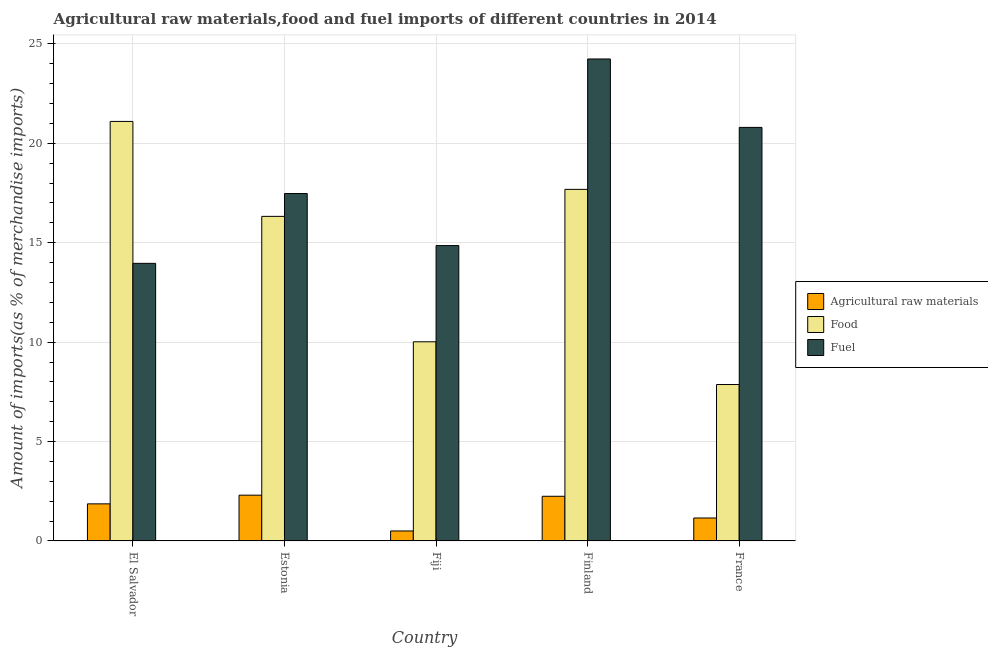How many different coloured bars are there?
Give a very brief answer. 3. Are the number of bars per tick equal to the number of legend labels?
Ensure brevity in your answer.  Yes. Are the number of bars on each tick of the X-axis equal?
Your response must be concise. Yes. What is the label of the 3rd group of bars from the left?
Your answer should be very brief. Fiji. In how many cases, is the number of bars for a given country not equal to the number of legend labels?
Your answer should be compact. 0. What is the percentage of raw materials imports in Finland?
Your answer should be very brief. 2.25. Across all countries, what is the maximum percentage of food imports?
Keep it short and to the point. 21.1. Across all countries, what is the minimum percentage of raw materials imports?
Offer a terse response. 0.5. In which country was the percentage of food imports maximum?
Make the answer very short. El Salvador. In which country was the percentage of fuel imports minimum?
Provide a short and direct response. El Salvador. What is the total percentage of raw materials imports in the graph?
Your response must be concise. 8.08. What is the difference between the percentage of raw materials imports in Finland and that in France?
Offer a terse response. 1.09. What is the difference between the percentage of raw materials imports in Estonia and the percentage of food imports in France?
Your answer should be compact. -5.56. What is the average percentage of fuel imports per country?
Offer a very short reply. 18.27. What is the difference between the percentage of fuel imports and percentage of food imports in El Salvador?
Provide a succinct answer. -7.14. What is the ratio of the percentage of food imports in Estonia to that in Finland?
Ensure brevity in your answer.  0.92. Is the difference between the percentage of fuel imports in Fiji and France greater than the difference between the percentage of raw materials imports in Fiji and France?
Provide a succinct answer. No. What is the difference between the highest and the second highest percentage of food imports?
Provide a short and direct response. 3.42. What is the difference between the highest and the lowest percentage of raw materials imports?
Your answer should be very brief. 1.8. What does the 2nd bar from the left in El Salvador represents?
Your answer should be very brief. Food. What does the 1st bar from the right in El Salvador represents?
Provide a succinct answer. Fuel. Is it the case that in every country, the sum of the percentage of raw materials imports and percentage of food imports is greater than the percentage of fuel imports?
Make the answer very short. No. Are all the bars in the graph horizontal?
Offer a terse response. No. Does the graph contain any zero values?
Your response must be concise. No. Where does the legend appear in the graph?
Keep it short and to the point. Center right. How many legend labels are there?
Offer a terse response. 3. What is the title of the graph?
Provide a succinct answer. Agricultural raw materials,food and fuel imports of different countries in 2014. Does "Ages 20-60" appear as one of the legend labels in the graph?
Make the answer very short. No. What is the label or title of the X-axis?
Your response must be concise. Country. What is the label or title of the Y-axis?
Offer a very short reply. Amount of imports(as % of merchandise imports). What is the Amount of imports(as % of merchandise imports) of Agricultural raw materials in El Salvador?
Your response must be concise. 1.87. What is the Amount of imports(as % of merchandise imports) of Food in El Salvador?
Offer a very short reply. 21.1. What is the Amount of imports(as % of merchandise imports) of Fuel in El Salvador?
Provide a short and direct response. 13.96. What is the Amount of imports(as % of merchandise imports) in Agricultural raw materials in Estonia?
Provide a short and direct response. 2.3. What is the Amount of imports(as % of merchandise imports) of Food in Estonia?
Ensure brevity in your answer.  16.32. What is the Amount of imports(as % of merchandise imports) of Fuel in Estonia?
Provide a succinct answer. 17.47. What is the Amount of imports(as % of merchandise imports) of Agricultural raw materials in Fiji?
Provide a short and direct response. 0.5. What is the Amount of imports(as % of merchandise imports) of Food in Fiji?
Your answer should be compact. 10.02. What is the Amount of imports(as % of merchandise imports) in Fuel in Fiji?
Keep it short and to the point. 14.86. What is the Amount of imports(as % of merchandise imports) in Agricultural raw materials in Finland?
Offer a very short reply. 2.25. What is the Amount of imports(as % of merchandise imports) in Food in Finland?
Provide a short and direct response. 17.68. What is the Amount of imports(as % of merchandise imports) in Fuel in Finland?
Provide a short and direct response. 24.24. What is the Amount of imports(as % of merchandise imports) of Agricultural raw materials in France?
Offer a terse response. 1.16. What is the Amount of imports(as % of merchandise imports) in Food in France?
Make the answer very short. 7.87. What is the Amount of imports(as % of merchandise imports) in Fuel in France?
Give a very brief answer. 20.8. Across all countries, what is the maximum Amount of imports(as % of merchandise imports) of Agricultural raw materials?
Offer a terse response. 2.3. Across all countries, what is the maximum Amount of imports(as % of merchandise imports) in Food?
Your answer should be compact. 21.1. Across all countries, what is the maximum Amount of imports(as % of merchandise imports) of Fuel?
Ensure brevity in your answer.  24.24. Across all countries, what is the minimum Amount of imports(as % of merchandise imports) of Agricultural raw materials?
Ensure brevity in your answer.  0.5. Across all countries, what is the minimum Amount of imports(as % of merchandise imports) of Food?
Ensure brevity in your answer.  7.87. Across all countries, what is the minimum Amount of imports(as % of merchandise imports) in Fuel?
Your answer should be compact. 13.96. What is the total Amount of imports(as % of merchandise imports) of Agricultural raw materials in the graph?
Provide a succinct answer. 8.08. What is the total Amount of imports(as % of merchandise imports) in Food in the graph?
Offer a very short reply. 72.99. What is the total Amount of imports(as % of merchandise imports) in Fuel in the graph?
Give a very brief answer. 91.33. What is the difference between the Amount of imports(as % of merchandise imports) in Agricultural raw materials in El Salvador and that in Estonia?
Your answer should be compact. -0.44. What is the difference between the Amount of imports(as % of merchandise imports) of Food in El Salvador and that in Estonia?
Your answer should be compact. 4.77. What is the difference between the Amount of imports(as % of merchandise imports) in Fuel in El Salvador and that in Estonia?
Your response must be concise. -3.51. What is the difference between the Amount of imports(as % of merchandise imports) of Agricultural raw materials in El Salvador and that in Fiji?
Offer a terse response. 1.36. What is the difference between the Amount of imports(as % of merchandise imports) of Food in El Salvador and that in Fiji?
Offer a terse response. 11.08. What is the difference between the Amount of imports(as % of merchandise imports) in Fuel in El Salvador and that in Fiji?
Your response must be concise. -0.89. What is the difference between the Amount of imports(as % of merchandise imports) in Agricultural raw materials in El Salvador and that in Finland?
Provide a succinct answer. -0.38. What is the difference between the Amount of imports(as % of merchandise imports) of Food in El Salvador and that in Finland?
Keep it short and to the point. 3.42. What is the difference between the Amount of imports(as % of merchandise imports) in Fuel in El Salvador and that in Finland?
Your answer should be compact. -10.28. What is the difference between the Amount of imports(as % of merchandise imports) of Agricultural raw materials in El Salvador and that in France?
Your response must be concise. 0.71. What is the difference between the Amount of imports(as % of merchandise imports) of Food in El Salvador and that in France?
Give a very brief answer. 13.23. What is the difference between the Amount of imports(as % of merchandise imports) of Fuel in El Salvador and that in France?
Give a very brief answer. -6.84. What is the difference between the Amount of imports(as % of merchandise imports) of Agricultural raw materials in Estonia and that in Fiji?
Offer a terse response. 1.8. What is the difference between the Amount of imports(as % of merchandise imports) of Food in Estonia and that in Fiji?
Your answer should be compact. 6.31. What is the difference between the Amount of imports(as % of merchandise imports) in Fuel in Estonia and that in Fiji?
Offer a terse response. 2.62. What is the difference between the Amount of imports(as % of merchandise imports) of Agricultural raw materials in Estonia and that in Finland?
Your response must be concise. 0.06. What is the difference between the Amount of imports(as % of merchandise imports) of Food in Estonia and that in Finland?
Offer a very short reply. -1.36. What is the difference between the Amount of imports(as % of merchandise imports) in Fuel in Estonia and that in Finland?
Provide a short and direct response. -6.77. What is the difference between the Amount of imports(as % of merchandise imports) of Agricultural raw materials in Estonia and that in France?
Offer a very short reply. 1.15. What is the difference between the Amount of imports(as % of merchandise imports) in Food in Estonia and that in France?
Keep it short and to the point. 8.46. What is the difference between the Amount of imports(as % of merchandise imports) in Fuel in Estonia and that in France?
Your response must be concise. -3.33. What is the difference between the Amount of imports(as % of merchandise imports) of Agricultural raw materials in Fiji and that in Finland?
Provide a succinct answer. -1.74. What is the difference between the Amount of imports(as % of merchandise imports) of Food in Fiji and that in Finland?
Your answer should be very brief. -7.67. What is the difference between the Amount of imports(as % of merchandise imports) of Fuel in Fiji and that in Finland?
Ensure brevity in your answer.  -9.38. What is the difference between the Amount of imports(as % of merchandise imports) of Agricultural raw materials in Fiji and that in France?
Offer a very short reply. -0.65. What is the difference between the Amount of imports(as % of merchandise imports) of Food in Fiji and that in France?
Your response must be concise. 2.15. What is the difference between the Amount of imports(as % of merchandise imports) in Fuel in Fiji and that in France?
Your answer should be very brief. -5.94. What is the difference between the Amount of imports(as % of merchandise imports) of Agricultural raw materials in Finland and that in France?
Provide a succinct answer. 1.09. What is the difference between the Amount of imports(as % of merchandise imports) of Food in Finland and that in France?
Provide a succinct answer. 9.81. What is the difference between the Amount of imports(as % of merchandise imports) in Fuel in Finland and that in France?
Ensure brevity in your answer.  3.44. What is the difference between the Amount of imports(as % of merchandise imports) in Agricultural raw materials in El Salvador and the Amount of imports(as % of merchandise imports) in Food in Estonia?
Keep it short and to the point. -14.46. What is the difference between the Amount of imports(as % of merchandise imports) of Agricultural raw materials in El Salvador and the Amount of imports(as % of merchandise imports) of Fuel in Estonia?
Your response must be concise. -15.61. What is the difference between the Amount of imports(as % of merchandise imports) in Food in El Salvador and the Amount of imports(as % of merchandise imports) in Fuel in Estonia?
Provide a short and direct response. 3.63. What is the difference between the Amount of imports(as % of merchandise imports) of Agricultural raw materials in El Salvador and the Amount of imports(as % of merchandise imports) of Food in Fiji?
Keep it short and to the point. -8.15. What is the difference between the Amount of imports(as % of merchandise imports) in Agricultural raw materials in El Salvador and the Amount of imports(as % of merchandise imports) in Fuel in Fiji?
Provide a short and direct response. -12.99. What is the difference between the Amount of imports(as % of merchandise imports) of Food in El Salvador and the Amount of imports(as % of merchandise imports) of Fuel in Fiji?
Keep it short and to the point. 6.24. What is the difference between the Amount of imports(as % of merchandise imports) in Agricultural raw materials in El Salvador and the Amount of imports(as % of merchandise imports) in Food in Finland?
Ensure brevity in your answer.  -15.82. What is the difference between the Amount of imports(as % of merchandise imports) of Agricultural raw materials in El Salvador and the Amount of imports(as % of merchandise imports) of Fuel in Finland?
Provide a short and direct response. -22.37. What is the difference between the Amount of imports(as % of merchandise imports) of Food in El Salvador and the Amount of imports(as % of merchandise imports) of Fuel in Finland?
Your response must be concise. -3.14. What is the difference between the Amount of imports(as % of merchandise imports) in Agricultural raw materials in El Salvador and the Amount of imports(as % of merchandise imports) in Food in France?
Your answer should be very brief. -6. What is the difference between the Amount of imports(as % of merchandise imports) of Agricultural raw materials in El Salvador and the Amount of imports(as % of merchandise imports) of Fuel in France?
Ensure brevity in your answer.  -18.93. What is the difference between the Amount of imports(as % of merchandise imports) of Food in El Salvador and the Amount of imports(as % of merchandise imports) of Fuel in France?
Your answer should be very brief. 0.3. What is the difference between the Amount of imports(as % of merchandise imports) in Agricultural raw materials in Estonia and the Amount of imports(as % of merchandise imports) in Food in Fiji?
Give a very brief answer. -7.71. What is the difference between the Amount of imports(as % of merchandise imports) in Agricultural raw materials in Estonia and the Amount of imports(as % of merchandise imports) in Fuel in Fiji?
Make the answer very short. -12.55. What is the difference between the Amount of imports(as % of merchandise imports) of Food in Estonia and the Amount of imports(as % of merchandise imports) of Fuel in Fiji?
Keep it short and to the point. 1.47. What is the difference between the Amount of imports(as % of merchandise imports) in Agricultural raw materials in Estonia and the Amount of imports(as % of merchandise imports) in Food in Finland?
Offer a very short reply. -15.38. What is the difference between the Amount of imports(as % of merchandise imports) in Agricultural raw materials in Estonia and the Amount of imports(as % of merchandise imports) in Fuel in Finland?
Provide a succinct answer. -21.94. What is the difference between the Amount of imports(as % of merchandise imports) of Food in Estonia and the Amount of imports(as % of merchandise imports) of Fuel in Finland?
Make the answer very short. -7.92. What is the difference between the Amount of imports(as % of merchandise imports) of Agricultural raw materials in Estonia and the Amount of imports(as % of merchandise imports) of Food in France?
Provide a short and direct response. -5.56. What is the difference between the Amount of imports(as % of merchandise imports) of Agricultural raw materials in Estonia and the Amount of imports(as % of merchandise imports) of Fuel in France?
Your answer should be very brief. -18.5. What is the difference between the Amount of imports(as % of merchandise imports) in Food in Estonia and the Amount of imports(as % of merchandise imports) in Fuel in France?
Your response must be concise. -4.47. What is the difference between the Amount of imports(as % of merchandise imports) of Agricultural raw materials in Fiji and the Amount of imports(as % of merchandise imports) of Food in Finland?
Your answer should be very brief. -17.18. What is the difference between the Amount of imports(as % of merchandise imports) of Agricultural raw materials in Fiji and the Amount of imports(as % of merchandise imports) of Fuel in Finland?
Give a very brief answer. -23.74. What is the difference between the Amount of imports(as % of merchandise imports) in Food in Fiji and the Amount of imports(as % of merchandise imports) in Fuel in Finland?
Your response must be concise. -14.22. What is the difference between the Amount of imports(as % of merchandise imports) of Agricultural raw materials in Fiji and the Amount of imports(as % of merchandise imports) of Food in France?
Provide a succinct answer. -7.36. What is the difference between the Amount of imports(as % of merchandise imports) of Agricultural raw materials in Fiji and the Amount of imports(as % of merchandise imports) of Fuel in France?
Offer a very short reply. -20.3. What is the difference between the Amount of imports(as % of merchandise imports) in Food in Fiji and the Amount of imports(as % of merchandise imports) in Fuel in France?
Provide a succinct answer. -10.78. What is the difference between the Amount of imports(as % of merchandise imports) of Agricultural raw materials in Finland and the Amount of imports(as % of merchandise imports) of Food in France?
Provide a succinct answer. -5.62. What is the difference between the Amount of imports(as % of merchandise imports) in Agricultural raw materials in Finland and the Amount of imports(as % of merchandise imports) in Fuel in France?
Your answer should be very brief. -18.55. What is the difference between the Amount of imports(as % of merchandise imports) in Food in Finland and the Amount of imports(as % of merchandise imports) in Fuel in France?
Keep it short and to the point. -3.12. What is the average Amount of imports(as % of merchandise imports) in Agricultural raw materials per country?
Provide a short and direct response. 1.62. What is the average Amount of imports(as % of merchandise imports) in Food per country?
Your response must be concise. 14.6. What is the average Amount of imports(as % of merchandise imports) of Fuel per country?
Keep it short and to the point. 18.27. What is the difference between the Amount of imports(as % of merchandise imports) in Agricultural raw materials and Amount of imports(as % of merchandise imports) in Food in El Salvador?
Your response must be concise. -19.23. What is the difference between the Amount of imports(as % of merchandise imports) in Agricultural raw materials and Amount of imports(as % of merchandise imports) in Fuel in El Salvador?
Your answer should be compact. -12.1. What is the difference between the Amount of imports(as % of merchandise imports) in Food and Amount of imports(as % of merchandise imports) in Fuel in El Salvador?
Offer a very short reply. 7.14. What is the difference between the Amount of imports(as % of merchandise imports) of Agricultural raw materials and Amount of imports(as % of merchandise imports) of Food in Estonia?
Make the answer very short. -14.02. What is the difference between the Amount of imports(as % of merchandise imports) in Agricultural raw materials and Amount of imports(as % of merchandise imports) in Fuel in Estonia?
Ensure brevity in your answer.  -15.17. What is the difference between the Amount of imports(as % of merchandise imports) in Food and Amount of imports(as % of merchandise imports) in Fuel in Estonia?
Your answer should be very brief. -1.15. What is the difference between the Amount of imports(as % of merchandise imports) of Agricultural raw materials and Amount of imports(as % of merchandise imports) of Food in Fiji?
Make the answer very short. -9.51. What is the difference between the Amount of imports(as % of merchandise imports) in Agricultural raw materials and Amount of imports(as % of merchandise imports) in Fuel in Fiji?
Your answer should be very brief. -14.35. What is the difference between the Amount of imports(as % of merchandise imports) of Food and Amount of imports(as % of merchandise imports) of Fuel in Fiji?
Make the answer very short. -4.84. What is the difference between the Amount of imports(as % of merchandise imports) of Agricultural raw materials and Amount of imports(as % of merchandise imports) of Food in Finland?
Provide a short and direct response. -15.43. What is the difference between the Amount of imports(as % of merchandise imports) in Agricultural raw materials and Amount of imports(as % of merchandise imports) in Fuel in Finland?
Make the answer very short. -21.99. What is the difference between the Amount of imports(as % of merchandise imports) of Food and Amount of imports(as % of merchandise imports) of Fuel in Finland?
Offer a terse response. -6.56. What is the difference between the Amount of imports(as % of merchandise imports) of Agricultural raw materials and Amount of imports(as % of merchandise imports) of Food in France?
Make the answer very short. -6.71. What is the difference between the Amount of imports(as % of merchandise imports) of Agricultural raw materials and Amount of imports(as % of merchandise imports) of Fuel in France?
Make the answer very short. -19.64. What is the difference between the Amount of imports(as % of merchandise imports) in Food and Amount of imports(as % of merchandise imports) in Fuel in France?
Offer a very short reply. -12.93. What is the ratio of the Amount of imports(as % of merchandise imports) of Agricultural raw materials in El Salvador to that in Estonia?
Make the answer very short. 0.81. What is the ratio of the Amount of imports(as % of merchandise imports) of Food in El Salvador to that in Estonia?
Keep it short and to the point. 1.29. What is the ratio of the Amount of imports(as % of merchandise imports) of Fuel in El Salvador to that in Estonia?
Your response must be concise. 0.8. What is the ratio of the Amount of imports(as % of merchandise imports) of Agricultural raw materials in El Salvador to that in Fiji?
Your answer should be very brief. 3.7. What is the ratio of the Amount of imports(as % of merchandise imports) of Food in El Salvador to that in Fiji?
Make the answer very short. 2.11. What is the ratio of the Amount of imports(as % of merchandise imports) of Fuel in El Salvador to that in Fiji?
Provide a succinct answer. 0.94. What is the ratio of the Amount of imports(as % of merchandise imports) in Agricultural raw materials in El Salvador to that in Finland?
Offer a very short reply. 0.83. What is the ratio of the Amount of imports(as % of merchandise imports) of Food in El Salvador to that in Finland?
Make the answer very short. 1.19. What is the ratio of the Amount of imports(as % of merchandise imports) in Fuel in El Salvador to that in Finland?
Your response must be concise. 0.58. What is the ratio of the Amount of imports(as % of merchandise imports) in Agricultural raw materials in El Salvador to that in France?
Keep it short and to the point. 1.62. What is the ratio of the Amount of imports(as % of merchandise imports) in Food in El Salvador to that in France?
Provide a succinct answer. 2.68. What is the ratio of the Amount of imports(as % of merchandise imports) in Fuel in El Salvador to that in France?
Your answer should be compact. 0.67. What is the ratio of the Amount of imports(as % of merchandise imports) in Agricultural raw materials in Estonia to that in Fiji?
Provide a short and direct response. 4.57. What is the ratio of the Amount of imports(as % of merchandise imports) in Food in Estonia to that in Fiji?
Provide a short and direct response. 1.63. What is the ratio of the Amount of imports(as % of merchandise imports) in Fuel in Estonia to that in Fiji?
Provide a short and direct response. 1.18. What is the ratio of the Amount of imports(as % of merchandise imports) of Agricultural raw materials in Estonia to that in Finland?
Your answer should be compact. 1.02. What is the ratio of the Amount of imports(as % of merchandise imports) of Food in Estonia to that in Finland?
Your answer should be compact. 0.92. What is the ratio of the Amount of imports(as % of merchandise imports) of Fuel in Estonia to that in Finland?
Provide a succinct answer. 0.72. What is the ratio of the Amount of imports(as % of merchandise imports) in Agricultural raw materials in Estonia to that in France?
Offer a terse response. 1.99. What is the ratio of the Amount of imports(as % of merchandise imports) in Food in Estonia to that in France?
Give a very brief answer. 2.07. What is the ratio of the Amount of imports(as % of merchandise imports) of Fuel in Estonia to that in France?
Give a very brief answer. 0.84. What is the ratio of the Amount of imports(as % of merchandise imports) in Agricultural raw materials in Fiji to that in Finland?
Your response must be concise. 0.22. What is the ratio of the Amount of imports(as % of merchandise imports) of Food in Fiji to that in Finland?
Keep it short and to the point. 0.57. What is the ratio of the Amount of imports(as % of merchandise imports) of Fuel in Fiji to that in Finland?
Give a very brief answer. 0.61. What is the ratio of the Amount of imports(as % of merchandise imports) in Agricultural raw materials in Fiji to that in France?
Make the answer very short. 0.44. What is the ratio of the Amount of imports(as % of merchandise imports) of Food in Fiji to that in France?
Your answer should be compact. 1.27. What is the ratio of the Amount of imports(as % of merchandise imports) of Fuel in Fiji to that in France?
Your response must be concise. 0.71. What is the ratio of the Amount of imports(as % of merchandise imports) of Agricultural raw materials in Finland to that in France?
Your answer should be compact. 1.94. What is the ratio of the Amount of imports(as % of merchandise imports) of Food in Finland to that in France?
Your response must be concise. 2.25. What is the ratio of the Amount of imports(as % of merchandise imports) of Fuel in Finland to that in France?
Keep it short and to the point. 1.17. What is the difference between the highest and the second highest Amount of imports(as % of merchandise imports) of Agricultural raw materials?
Provide a succinct answer. 0.06. What is the difference between the highest and the second highest Amount of imports(as % of merchandise imports) in Food?
Give a very brief answer. 3.42. What is the difference between the highest and the second highest Amount of imports(as % of merchandise imports) of Fuel?
Offer a terse response. 3.44. What is the difference between the highest and the lowest Amount of imports(as % of merchandise imports) of Agricultural raw materials?
Your answer should be compact. 1.8. What is the difference between the highest and the lowest Amount of imports(as % of merchandise imports) in Food?
Keep it short and to the point. 13.23. What is the difference between the highest and the lowest Amount of imports(as % of merchandise imports) in Fuel?
Offer a terse response. 10.28. 